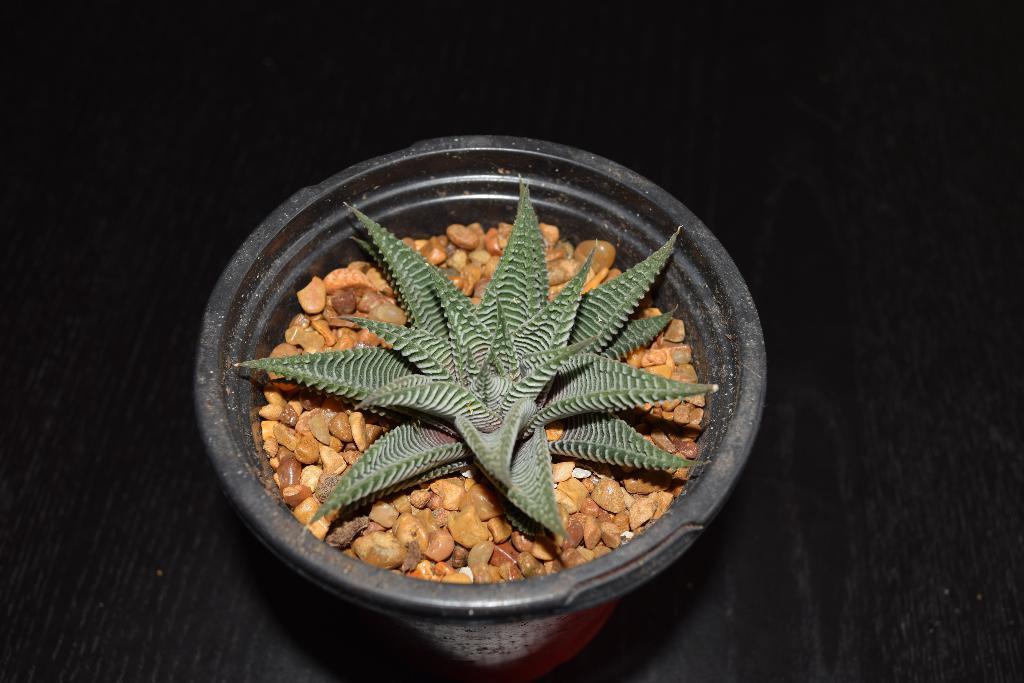Could you give a brief overview of what you see in this image? In this image we can see a flower pot in which small stones and small plant are there. 